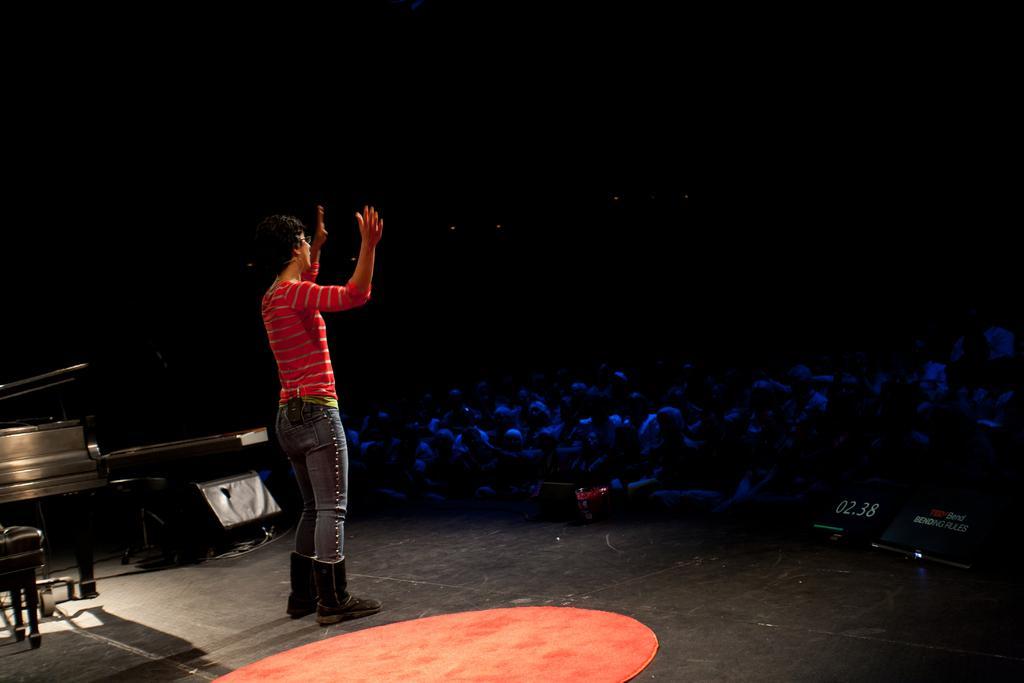What is the person in the image doing? The person is standing on the floor. What is the person wearing? The person is wearing a red t-shirt. What else can be seen in the image besides the standing person? There are musical instruments and persons sitting on chairs in the image. What type of punishment is being administered to the ants in the image? There are no ants present in the image, so no punishment is being administered. What is the river's depth in the image? There is no river present in the image. 